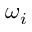<formula> <loc_0><loc_0><loc_500><loc_500>\omega _ { i }</formula> 